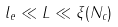<formula> <loc_0><loc_0><loc_500><loc_500>l _ { e } \ll L \ll \xi ( N _ { c } )</formula> 